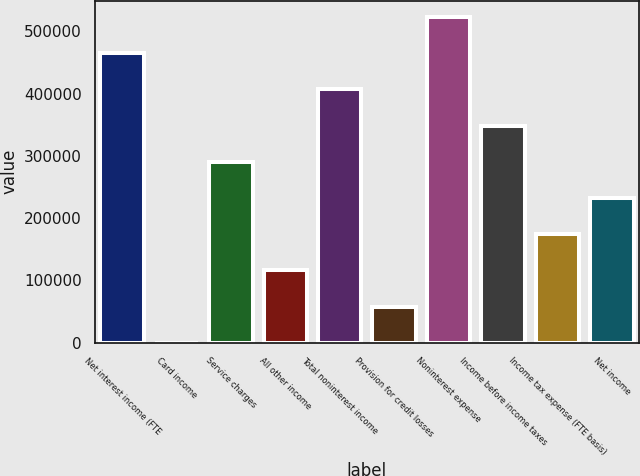<chart> <loc_0><loc_0><loc_500><loc_500><bar_chart><fcel>Net interest income (FTE<fcel>Card income<fcel>Service charges<fcel>All other income<fcel>Total noninterest income<fcel>Provision for credit losses<fcel>Noninterest expense<fcel>Income before income taxes<fcel>Income tax expense (FTE basis)<fcel>Net income<nl><fcel>464699<fcel>68<fcel>290462<fcel>116226<fcel>406620<fcel>58146.9<fcel>522778<fcel>348541<fcel>174305<fcel>232384<nl></chart> 